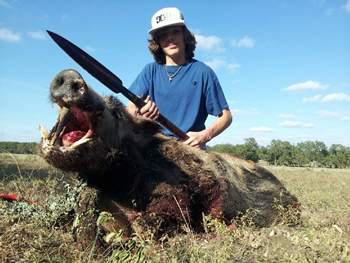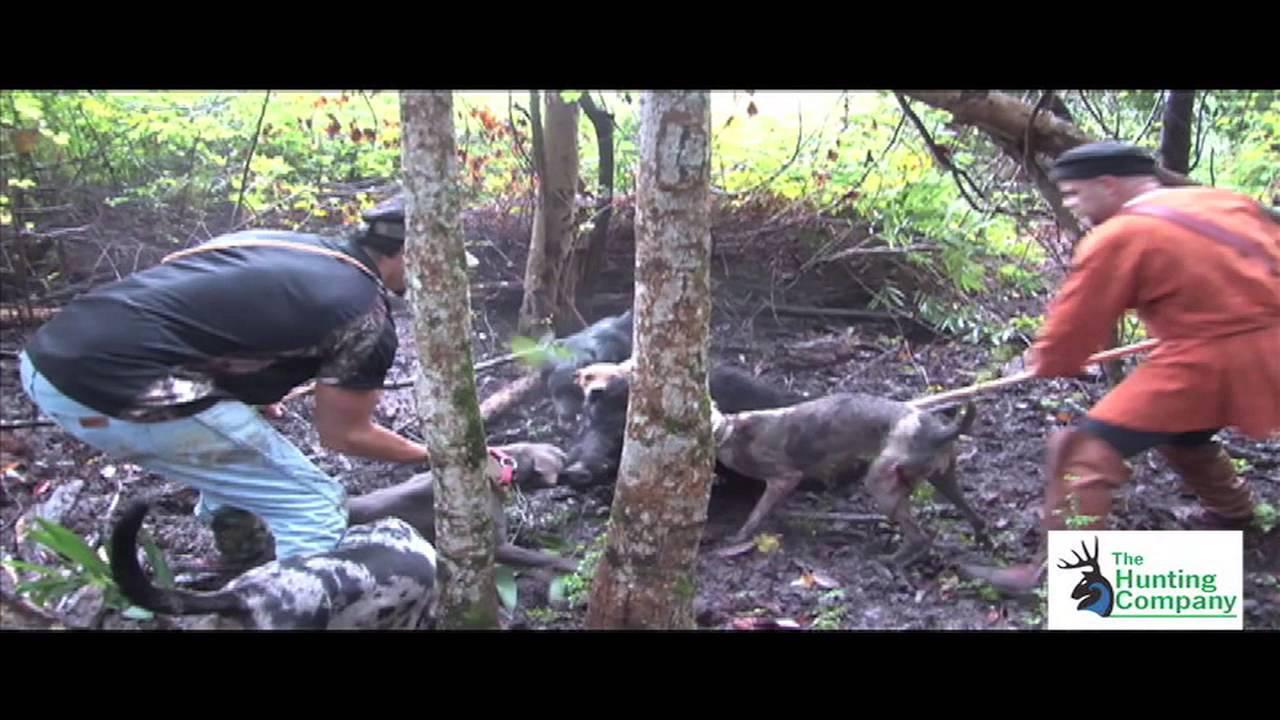The first image is the image on the left, the second image is the image on the right. Analyze the images presented: Is the assertion "there is a dead boar with it's mouth wide open and a man with a long blade spear sitting behind it" valid? Answer yes or no. Yes. The first image is the image on the left, the second image is the image on the right. Evaluate the accuracy of this statement regarding the images: "A male person grasping a spear in both hands is by a killed hog positioned on the ground with its open-mouthed face toward the camera.". Is it true? Answer yes or no. Yes. 